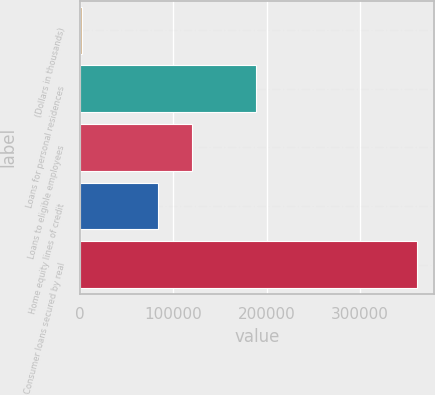Convert chart. <chart><loc_0><loc_0><loc_500><loc_500><bar_chart><fcel>(Dollars in thousands)<fcel>Loans for personal residences<fcel>Loans to eligible employees<fcel>Home equity lines of credit<fcel>Consumer loans secured by real<nl><fcel>2010<fcel>189039<fcel>120124<fcel>84155<fcel>361704<nl></chart> 